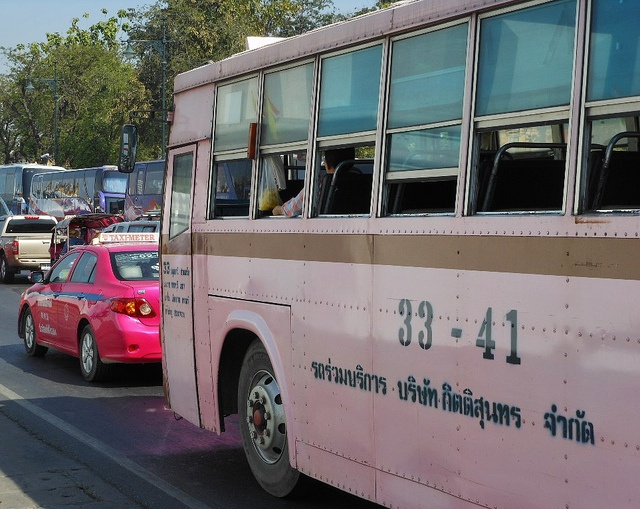Describe the objects in this image and their specific colors. I can see bus in lightblue, darkgray, black, and gray tones, car in lightblue, black, brown, and maroon tones, bus in lightblue, gray, darkgray, and black tones, truck in lightblue, black, darkgray, ivory, and gray tones, and bus in lightblue, gray, blue, and darkgray tones in this image. 